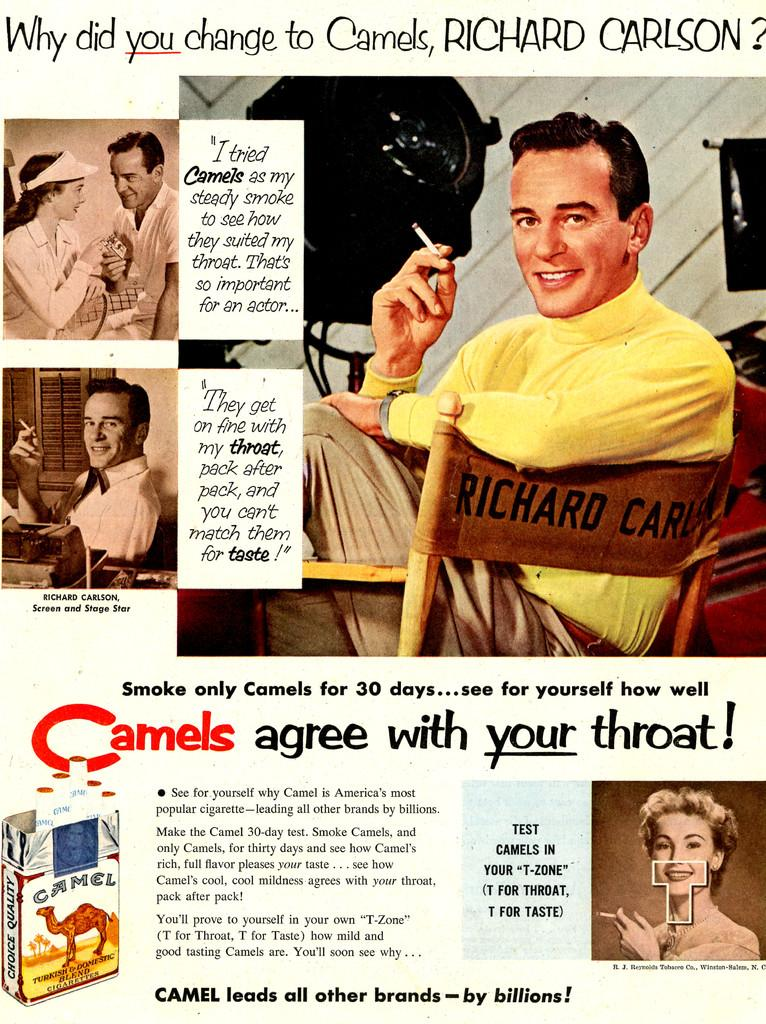<image>
Relay a brief, clear account of the picture shown. An old magazine page with a Camel pack of cigarettes in the corner 